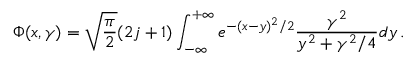<formula> <loc_0><loc_0><loc_500><loc_500>\Phi ( x , \gamma ) = \sqrt { \frac { \pi } { 2 } } ( 2 j + 1 ) \int _ { - \infty } ^ { + \infty } e ^ { - ( x - y ) ^ { 2 } / 2 } \frac { \gamma ^ { 2 } } { y ^ { 2 } + \gamma ^ { 2 } / 4 } d y \, .</formula> 